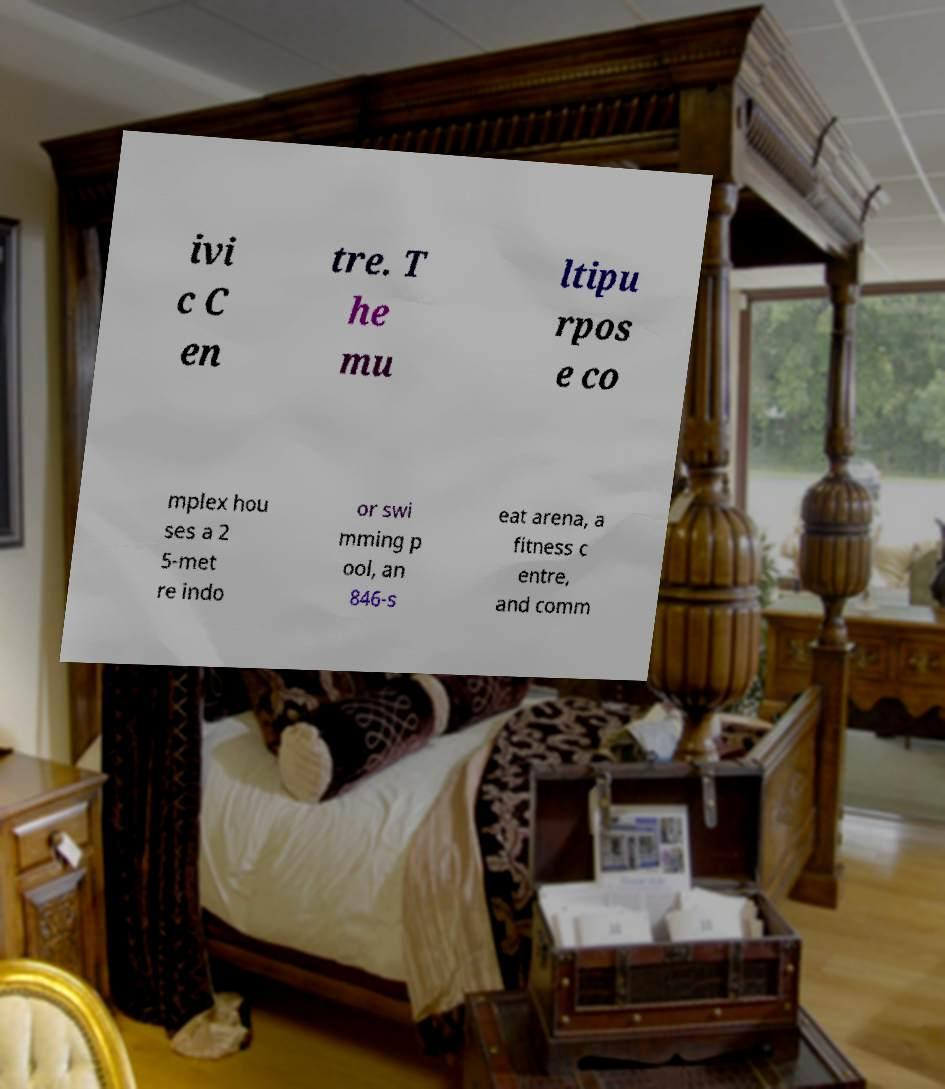Please read and relay the text visible in this image. What does it say? ivi c C en tre. T he mu ltipu rpos e co mplex hou ses a 2 5-met re indo or swi mming p ool, an 846-s eat arena, a fitness c entre, and comm 